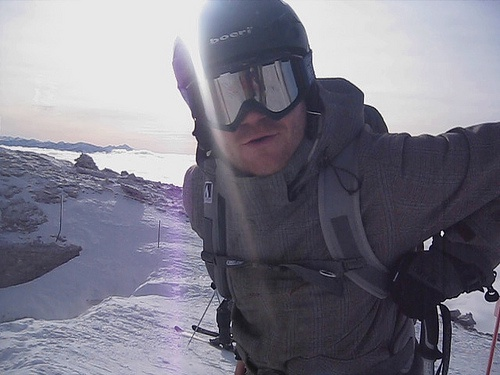Describe the objects in this image and their specific colors. I can see people in lightgray, black, and gray tones, backpack in lightgray, black, and gray tones, skis in lightgray, darkgray, and gray tones, and skis in lightgray, black, and gray tones in this image. 